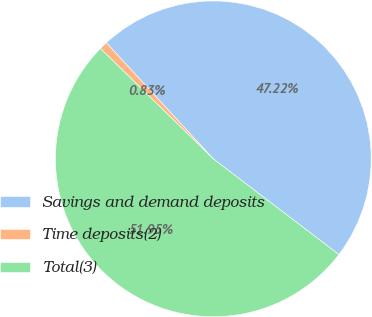<chart> <loc_0><loc_0><loc_500><loc_500><pie_chart><fcel>Savings and demand deposits<fcel>Time deposits(2)<fcel>Total(3)<nl><fcel>47.22%<fcel>0.83%<fcel>51.95%<nl></chart> 